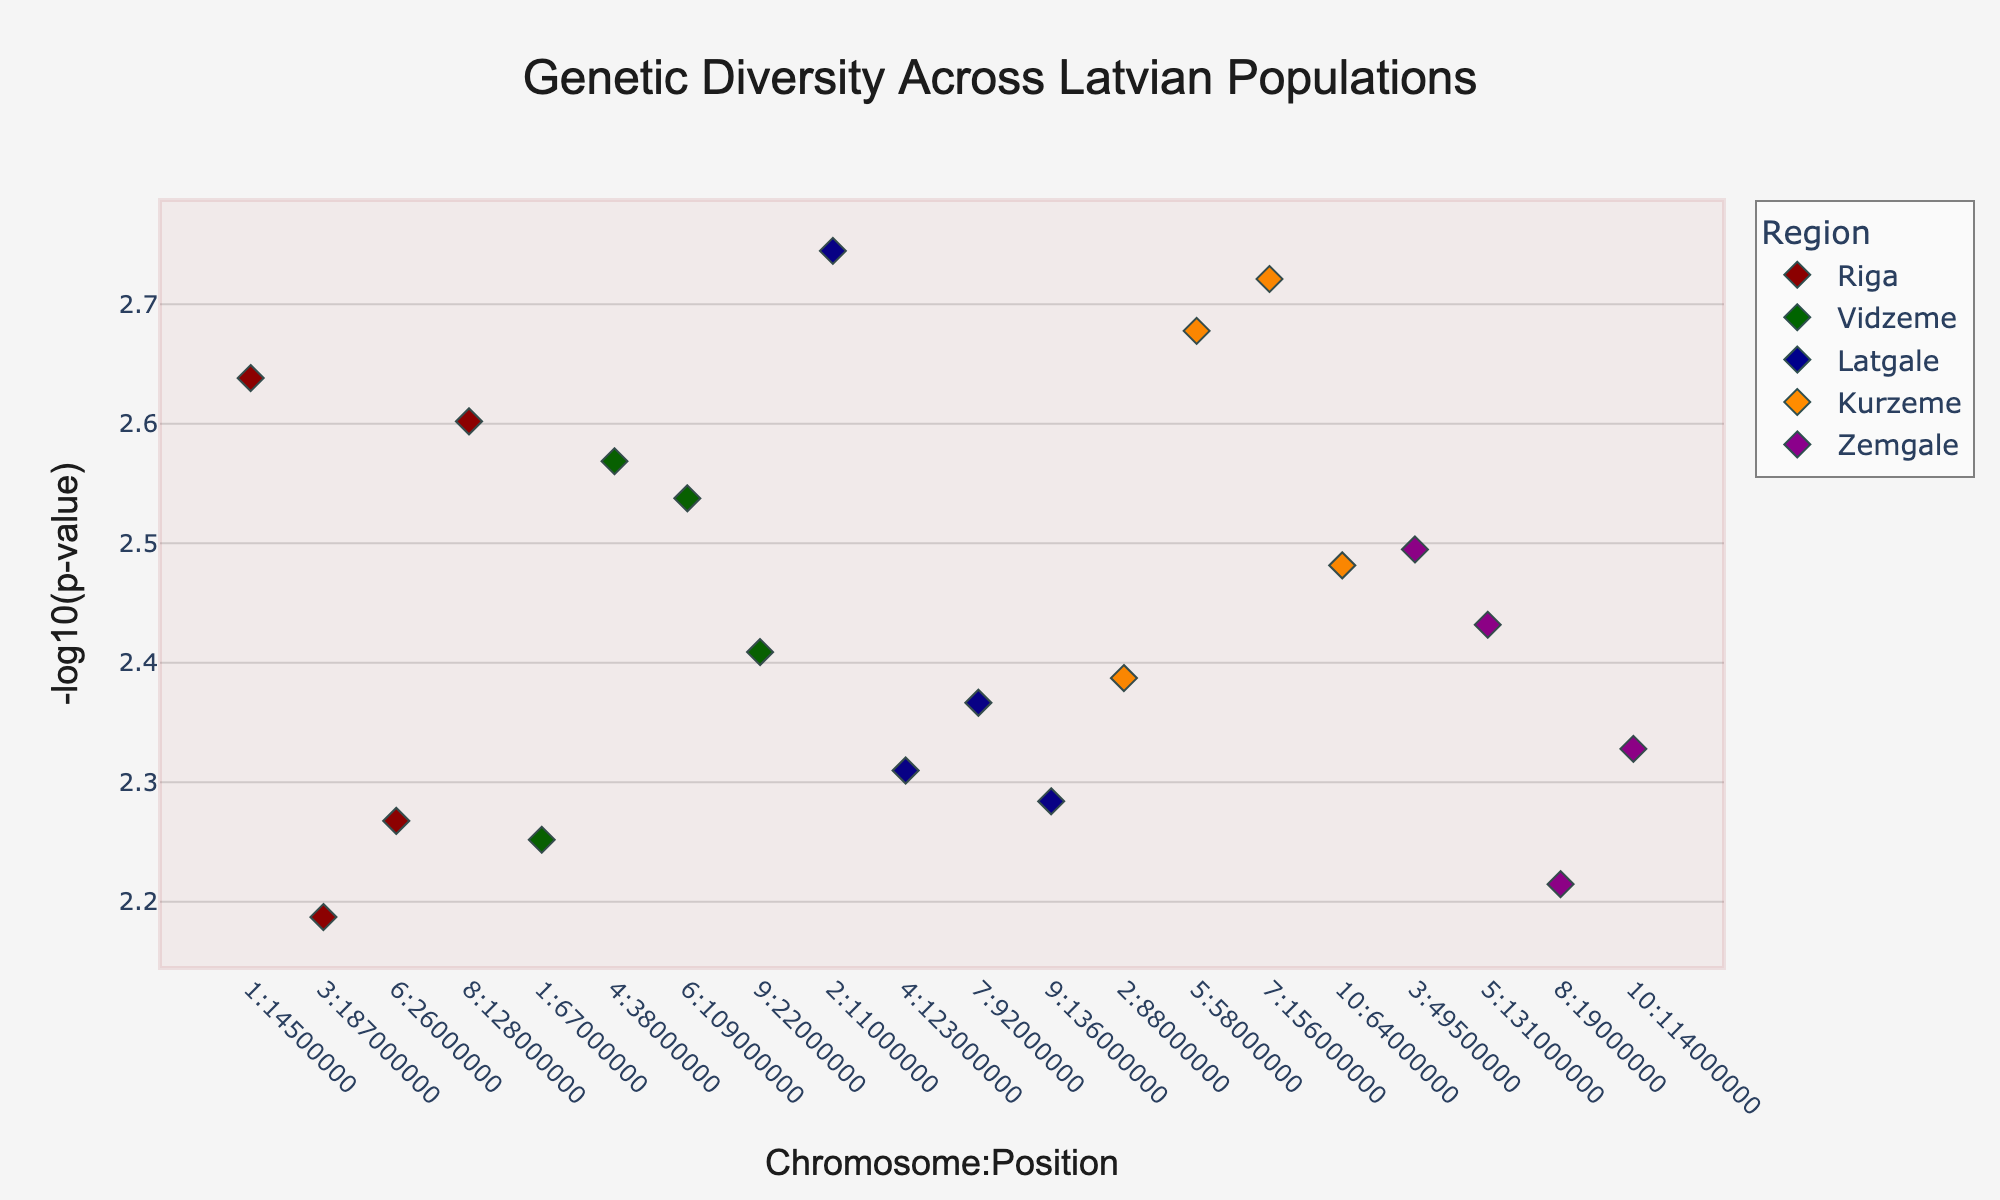**Question 1**: What is the title of the plot? The title is typically displayed at the top of the figure, centered and often in a larger or distinct font. This figure has a clear title at the top.
Answer: Genetic Diversity Across Latvian Populations **Question 2**: Which region has the highest data point on the Y-axis? To find this, we look for the dot that is highest up on the Y-axis, indicating the maximum -log10(p-value).
Answer: Riga **Question 3**: How many SNPs are shown for Riga? By counting the number of markers (dots) corresponding to Riga, we determine the number of SNPs.
Answer: 4 **Question 4**: Which chromosomes have SNPs from Vidzeme? Look at the dots colored in the specific color for Vidzeme and note their corresponding X-axis positions (chromosome numbers).
Answer: Chromosome 1, 4, 6, 9 **Question 5**: On which chromosome and position is the SNP with the lowest p-value from Latgale? The lowest p-value corresponds to the highest -log10(p) value on the Y-axis. Identify the highest dot colored for Latgale and note its position on the X-axis.
Answer: Chromosome 2 at Position 11000000 **Question 6**: Compare the average -log10(p) values for Riga and Zemgale. Which region has a higher average? Calculate the average -log10(p) for each region by summing and dividing by the number of data points, then compare the two averages.
Answer: Riga **Question 7**: What is the color used for Kurzeme? Locate the region-specific color in the legend or observe the color of the dots labeled Kurzeme.
Answer: Dark Orange **Question 8**: What is the range of positions for the SNPs on Chromosome 8? Identify all SNPs on Chromosome 8 and note the minimum and maximum positions.
Answer: 19000000 to 128000000 **Question 9**: Identify the chromosome having SNPs from the most different regions. How many different regions are represented on this chromosome? Look across all chromosomes to see which one has markers from the most unique regions. Count the distinct regions represented.
Answer: Chromosome 5, with SNPs from 2 regions **Question 10**: What is the lowest -log10(p) value on the entire plot, and which SNP does it correspond to? Locate the lowest value on the Y-axis, which would be near the bottom, and identify the corresponding SNP.
Answer: SNP rs12124819 with -log10(p) ~2.251 